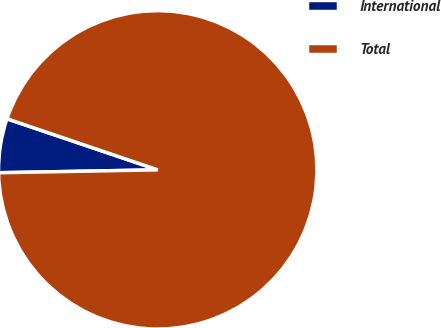<chart> <loc_0><loc_0><loc_500><loc_500><pie_chart><fcel>International<fcel>Total<nl><fcel>5.49%<fcel>94.51%<nl></chart> 